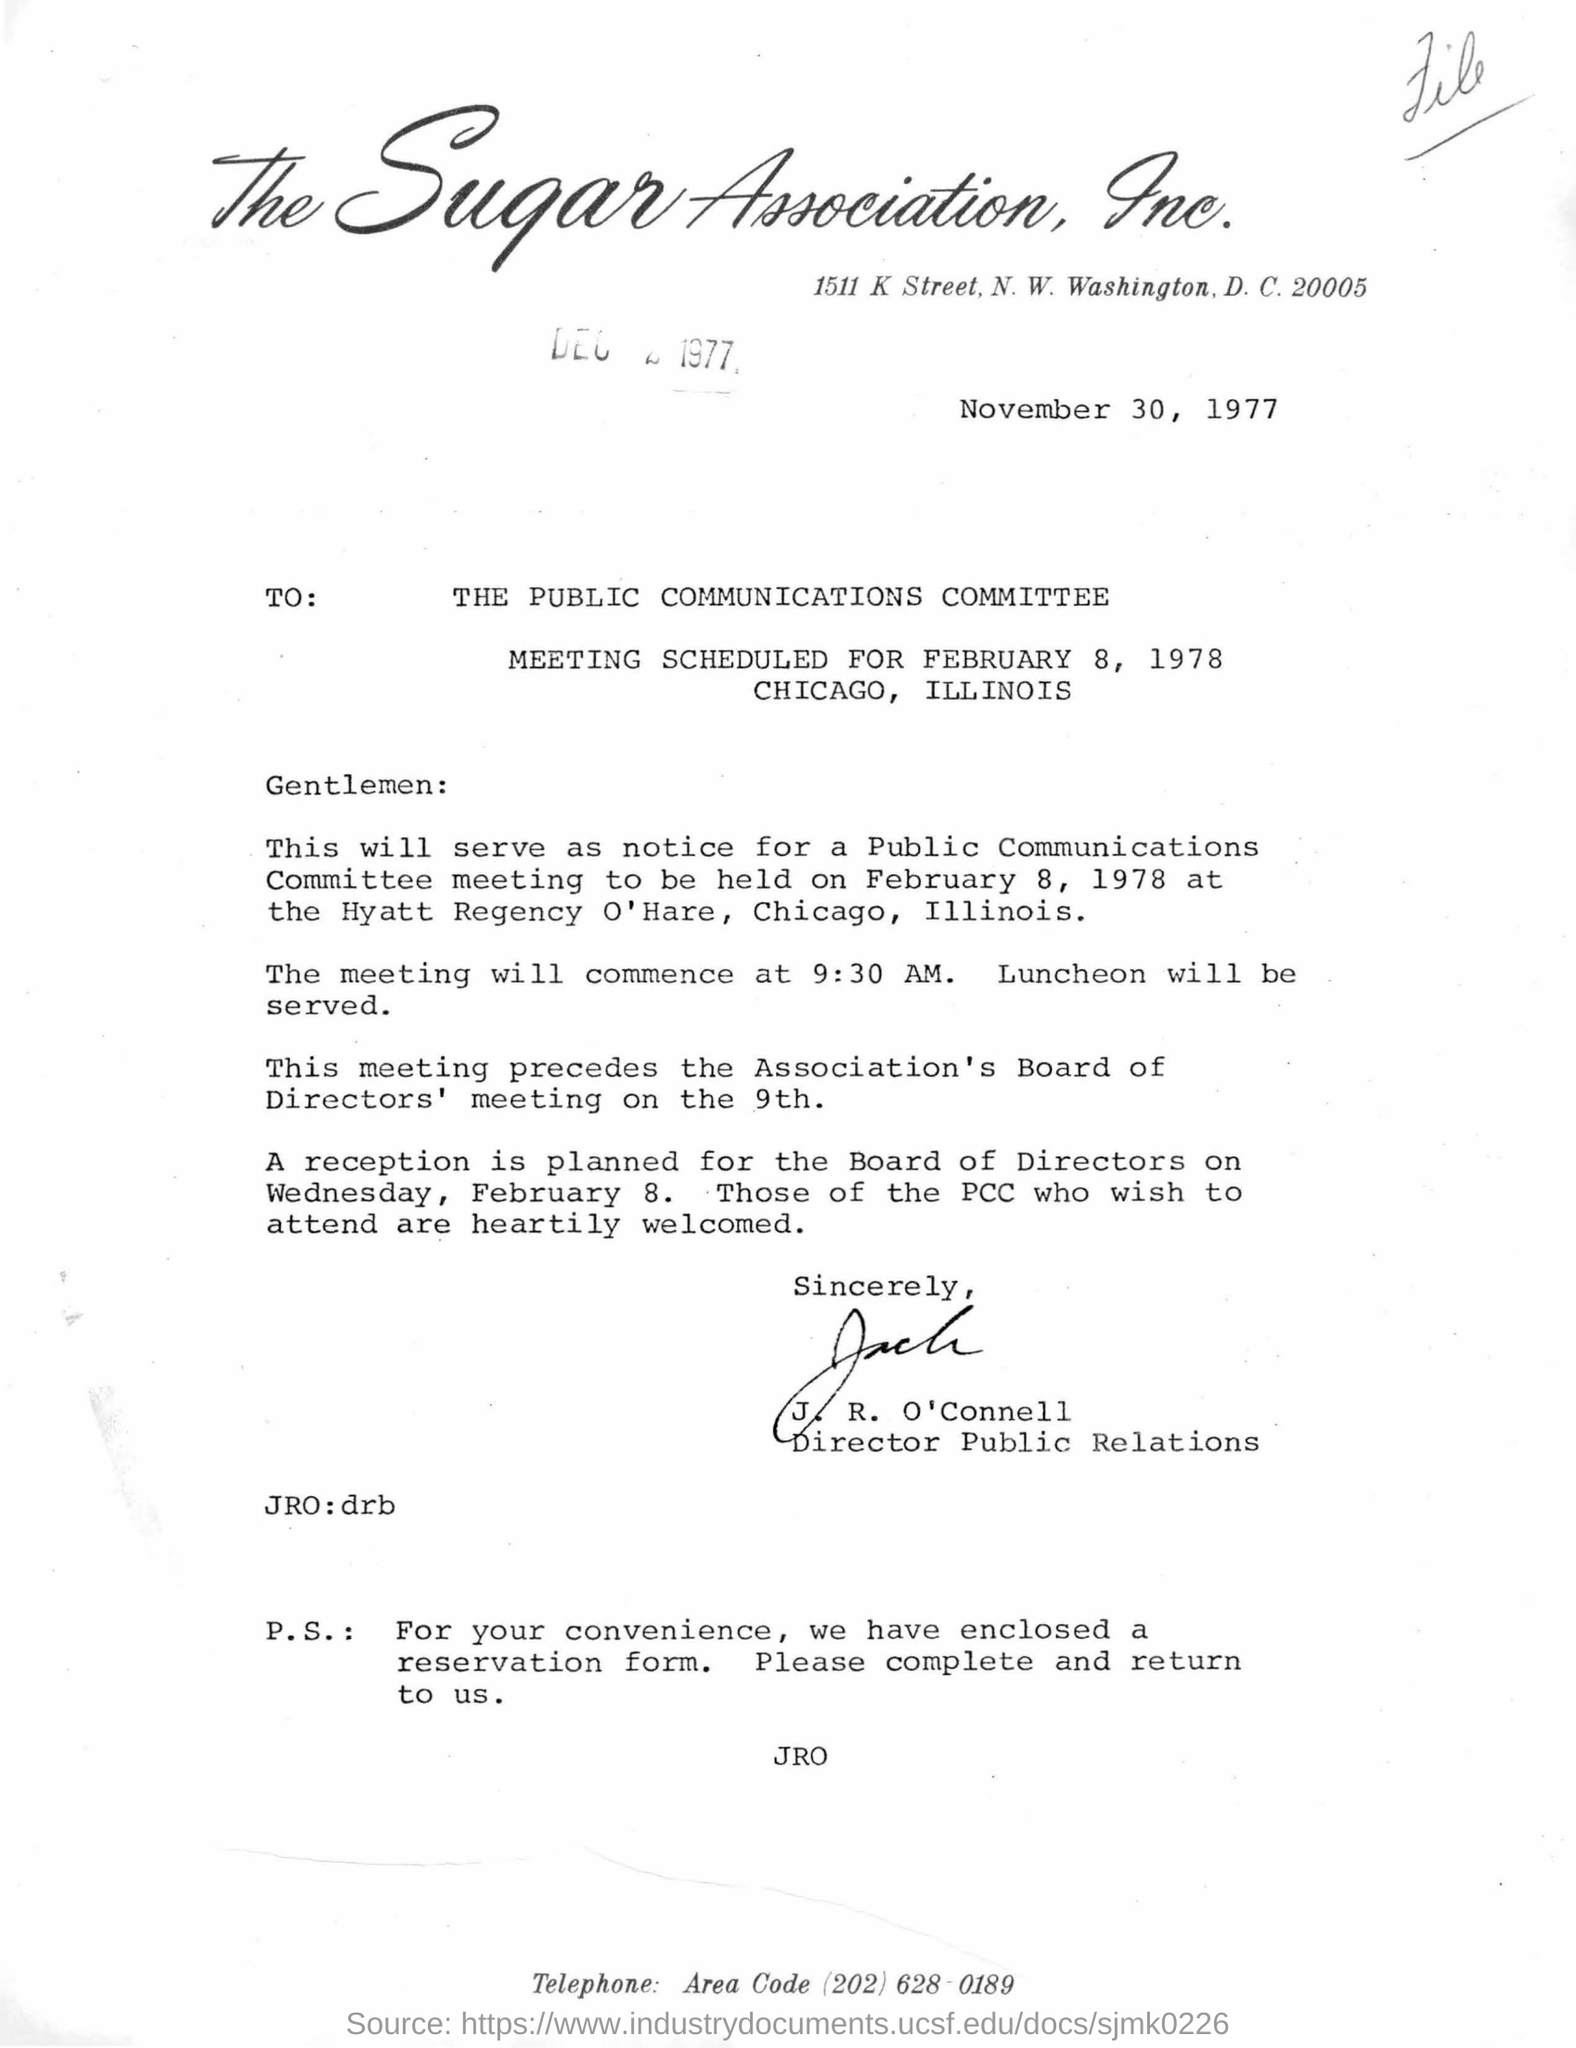When will the meeting commence?
Give a very brief answer. At 9 : 30 am. 